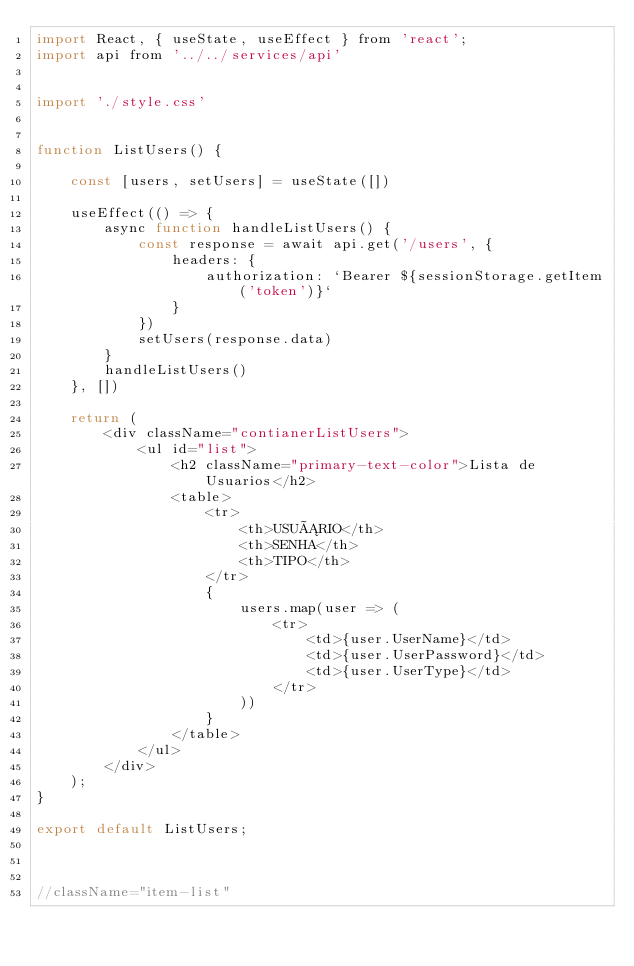<code> <loc_0><loc_0><loc_500><loc_500><_JavaScript_>import React, { useState, useEffect } from 'react';
import api from '../../services/api'


import './style.css'


function ListUsers() {

    const [users, setUsers] = useState([])

    useEffect(() => {
        async function handleListUsers() {
            const response = await api.get('/users', {
                headers: {
                    authorization: `Bearer ${sessionStorage.getItem('token')}`
                }
            })
            setUsers(response.data)
        }
        handleListUsers()
    }, [])

    return (
        <div className="contianerListUsers">
            <ul id="list">
                <h2 className="primary-text-color">Lista de Usuarios</h2>
                <table>
                    <tr>
                        <th>USUÁRIO</th>
                        <th>SENHA</th>
                        <th>TIPO</th>
                    </tr>
                    {
                        users.map(user => (
                            <tr>
                                <td>{user.UserName}</td>
                                <td>{user.UserPassword}</td>
                                <td>{user.UserType}</td>
                            </tr>
                        ))
                    }
                </table>
            </ul>
        </div>
    );
}

export default ListUsers;



//className="item-list"</code> 